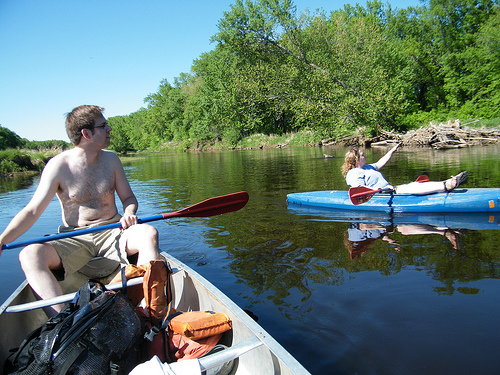<image>
Is there a man next to the women? Yes. The man is positioned adjacent to the women, located nearby in the same general area. Is the paddle in the water? No. The paddle is not contained within the water. These objects have a different spatial relationship. 